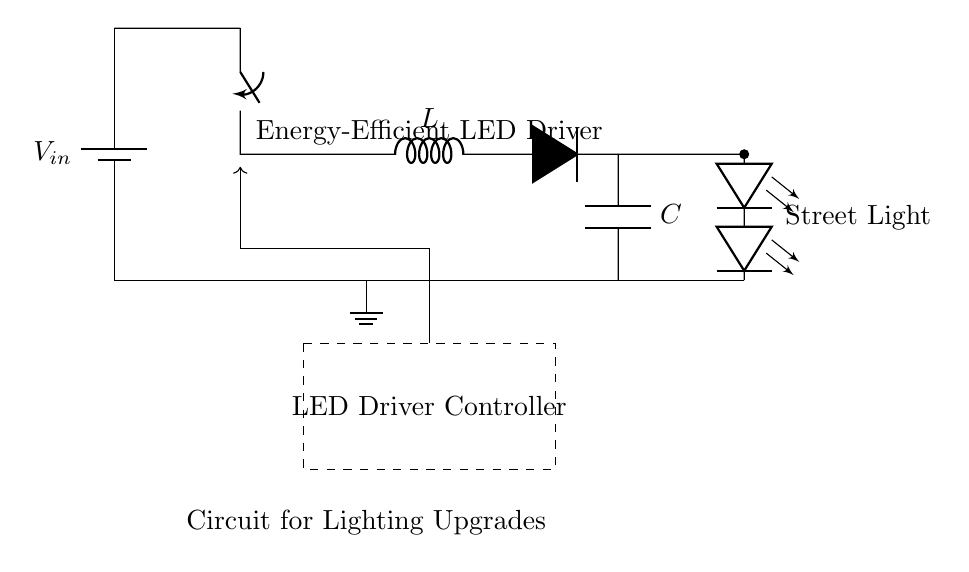What voltage is supplied to the circuit? The voltage is indicated as V_in coming from the battery component. It's the input voltage to the amplifier circuit.
Answer: V_in What component is used to store energy in this circuit? The inductor component labeled 'L' stores energy through its magnetic field when current flows through it, which is a typical function of inductors in circuits.
Answer: Inductor What is the role of the LED Driver Controller? The LED Driver Controller regulates the current and voltage supplied to the LED array, ensuring energy efficiency and proper operation of the LEDs during street lighting.
Answer: Regulation How many LEDs are present in the circuit? There are two LED components indicated in the circuit diagram, both labeled as leDo for the LED array.
Answer: Two LEDs What type of component is used to prevent reverse current? The diode component labeled as 'D' is used to prevent reverse current, allowing current to flow in only one direction, essential for maintaining circuit integrity.
Answer: Diode Why is the capacitor included in the circuit? The capacitor labeled 'C' is included to smooth out voltage fluctuations and provide stability in the output voltage to the LED array, enhancing energy efficiency.
Answer: Smoothing voltage What feature characterizes the energy-efficient aspect of this LED driver circuit? The combination of the switching circuit and LED Driver Controller allows this circuit to efficiently manage power delivery to the LEDs, making it energy-efficient compared to traditional drivers.
Answer: Efficiency management 